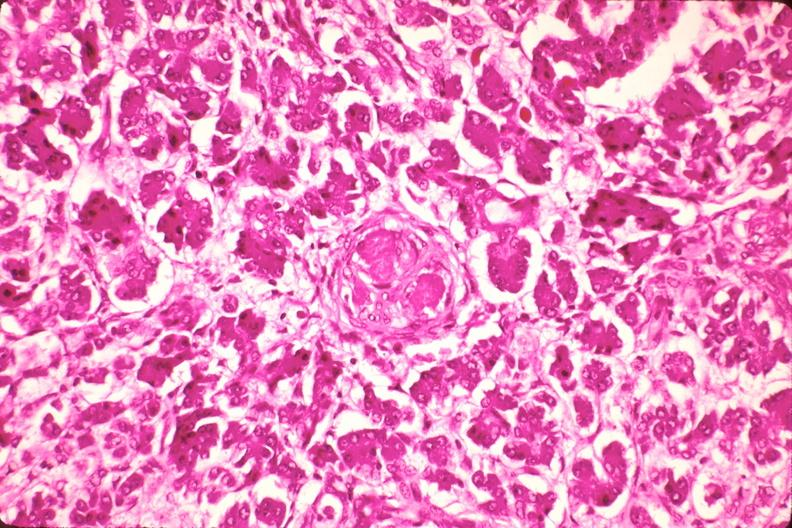what does this image show?
Answer the question using a single word or phrase. Pancreas 